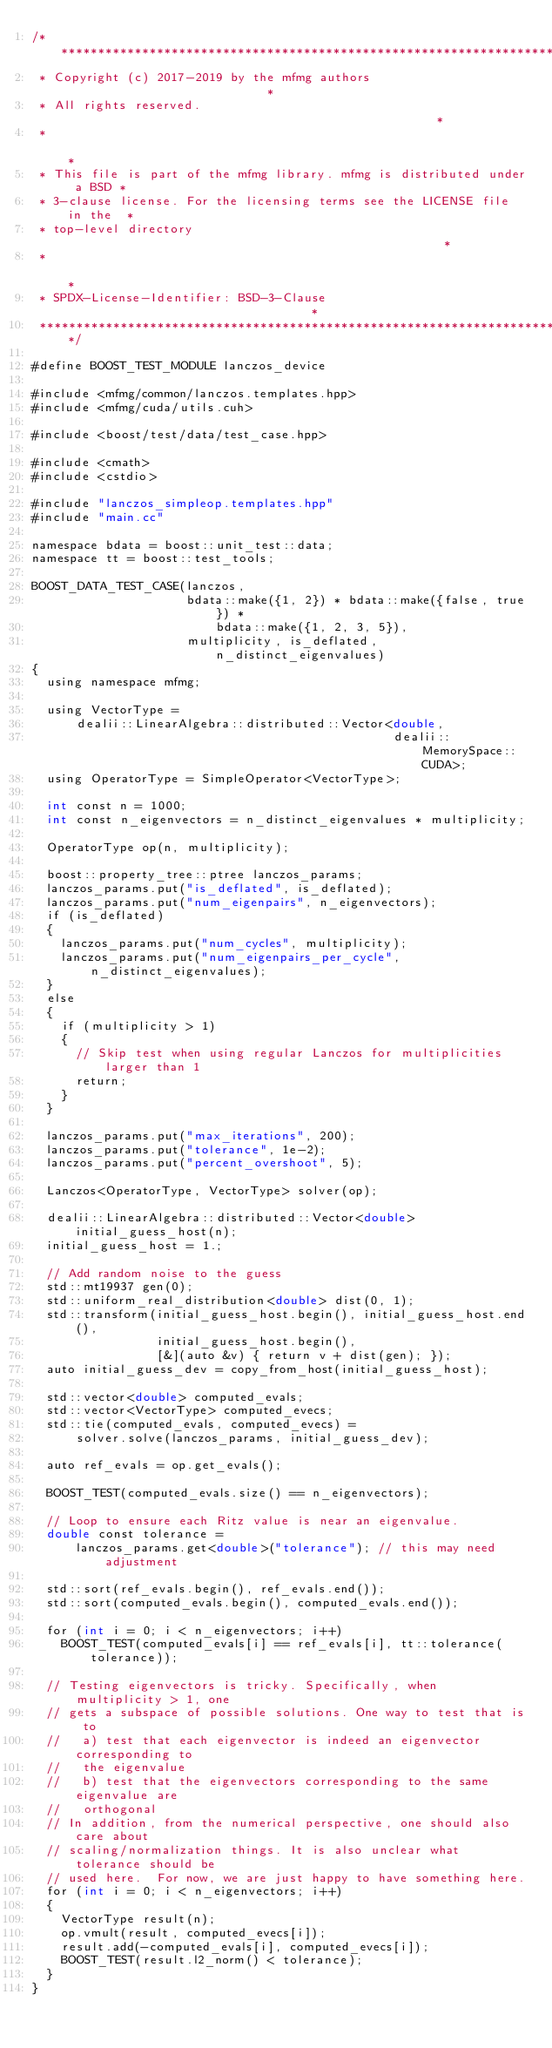<code> <loc_0><loc_0><loc_500><loc_500><_Cuda_>/**************************************************************************
 * Copyright (c) 2017-2019 by the mfmg authors                            *
 * All rights reserved.                                                   *
 *                                                                        *
 * This file is part of the mfmg library. mfmg is distributed under a BSD *
 * 3-clause license. For the licensing terms see the LICENSE file in the  *
 * top-level directory                                                    *
 *                                                                        *
 * SPDX-License-Identifier: BSD-3-Clause                                  *
 **************************************************************************/

#define BOOST_TEST_MODULE lanczos_device

#include <mfmg/common/lanczos.templates.hpp>
#include <mfmg/cuda/utils.cuh>

#include <boost/test/data/test_case.hpp>

#include <cmath>
#include <cstdio>

#include "lanczos_simpleop.templates.hpp"
#include "main.cc"

namespace bdata = boost::unit_test::data;
namespace tt = boost::test_tools;

BOOST_DATA_TEST_CASE(lanczos,
                     bdata::make({1, 2}) * bdata::make({false, true}) *
                         bdata::make({1, 2, 3, 5}),
                     multiplicity, is_deflated, n_distinct_eigenvalues)
{
  using namespace mfmg;

  using VectorType =
      dealii::LinearAlgebra::distributed::Vector<double,
                                                 dealii::MemorySpace::CUDA>;
  using OperatorType = SimpleOperator<VectorType>;

  int const n = 1000;
  int const n_eigenvectors = n_distinct_eigenvalues * multiplicity;

  OperatorType op(n, multiplicity);

  boost::property_tree::ptree lanczos_params;
  lanczos_params.put("is_deflated", is_deflated);
  lanczos_params.put("num_eigenpairs", n_eigenvectors);
  if (is_deflated)
  {
    lanczos_params.put("num_cycles", multiplicity);
    lanczos_params.put("num_eigenpairs_per_cycle", n_distinct_eigenvalues);
  }
  else
  {
    if (multiplicity > 1)
    {
      // Skip test when using regular Lanczos for multiplicities larger than 1
      return;
    }
  }

  lanczos_params.put("max_iterations", 200);
  lanczos_params.put("tolerance", 1e-2);
  lanczos_params.put("percent_overshoot", 5);

  Lanczos<OperatorType, VectorType> solver(op);

  dealii::LinearAlgebra::distributed::Vector<double> initial_guess_host(n);
  initial_guess_host = 1.;

  // Add random noise to the guess
  std::mt19937 gen(0);
  std::uniform_real_distribution<double> dist(0, 1);
  std::transform(initial_guess_host.begin(), initial_guess_host.end(),
                 initial_guess_host.begin(),
                 [&](auto &v) { return v + dist(gen); });
  auto initial_guess_dev = copy_from_host(initial_guess_host);

  std::vector<double> computed_evals;
  std::vector<VectorType> computed_evecs;
  std::tie(computed_evals, computed_evecs) =
      solver.solve(lanczos_params, initial_guess_dev);

  auto ref_evals = op.get_evals();

  BOOST_TEST(computed_evals.size() == n_eigenvectors);

  // Loop to ensure each Ritz value is near an eigenvalue.
  double const tolerance =
      lanczos_params.get<double>("tolerance"); // this may need adjustment

  std::sort(ref_evals.begin(), ref_evals.end());
  std::sort(computed_evals.begin(), computed_evals.end());

  for (int i = 0; i < n_eigenvectors; i++)
    BOOST_TEST(computed_evals[i] == ref_evals[i], tt::tolerance(tolerance));

  // Testing eigenvectors is tricky. Specifically, when multiplicity > 1, one
  // gets a subspace of possible solutions. One way to test that is to
  //   a) test that each eigenvector is indeed an eigenvector corresponding to
  //   the eigenvalue
  //   b) test that the eigenvectors corresponding to the same eigenvalue are
  //   orthogonal
  // In addition, from the numerical perspective, one should also care about
  // scaling/normalization things. It is also unclear what tolerance should be
  // used here.  For now, we are just happy to have something here.
  for (int i = 0; i < n_eigenvectors; i++)
  {
    VectorType result(n);
    op.vmult(result, computed_evecs[i]);
    result.add(-computed_evals[i], computed_evecs[i]);
    BOOST_TEST(result.l2_norm() < tolerance);
  }
}
</code> 